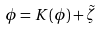Convert formula to latex. <formula><loc_0><loc_0><loc_500><loc_500>\phi = K ( \phi ) + \tilde { \zeta }</formula> 